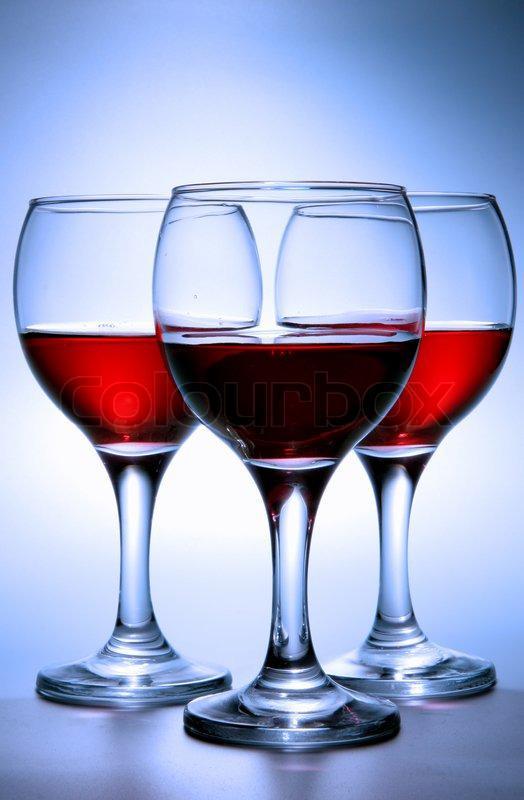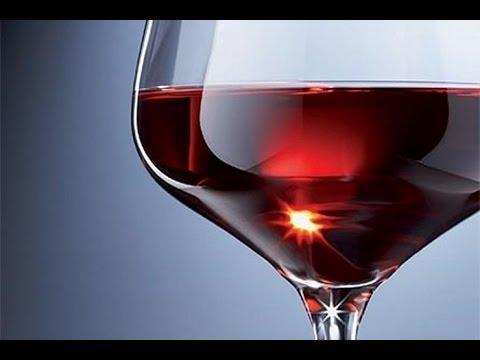The first image is the image on the left, the second image is the image on the right. Considering the images on both sides, is "Left image shows exactly three half-full wine glasses arranged in a row." valid? Answer yes or no. Yes. The first image is the image on the left, the second image is the image on the right. Evaluate the accuracy of this statement regarding the images: "The image on the right has three glasses of red wine.". Is it true? Answer yes or no. No. 